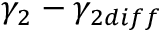Convert formula to latex. <formula><loc_0><loc_0><loc_500><loc_500>\gamma _ { 2 } - \gamma _ { 2 d i f f }</formula> 